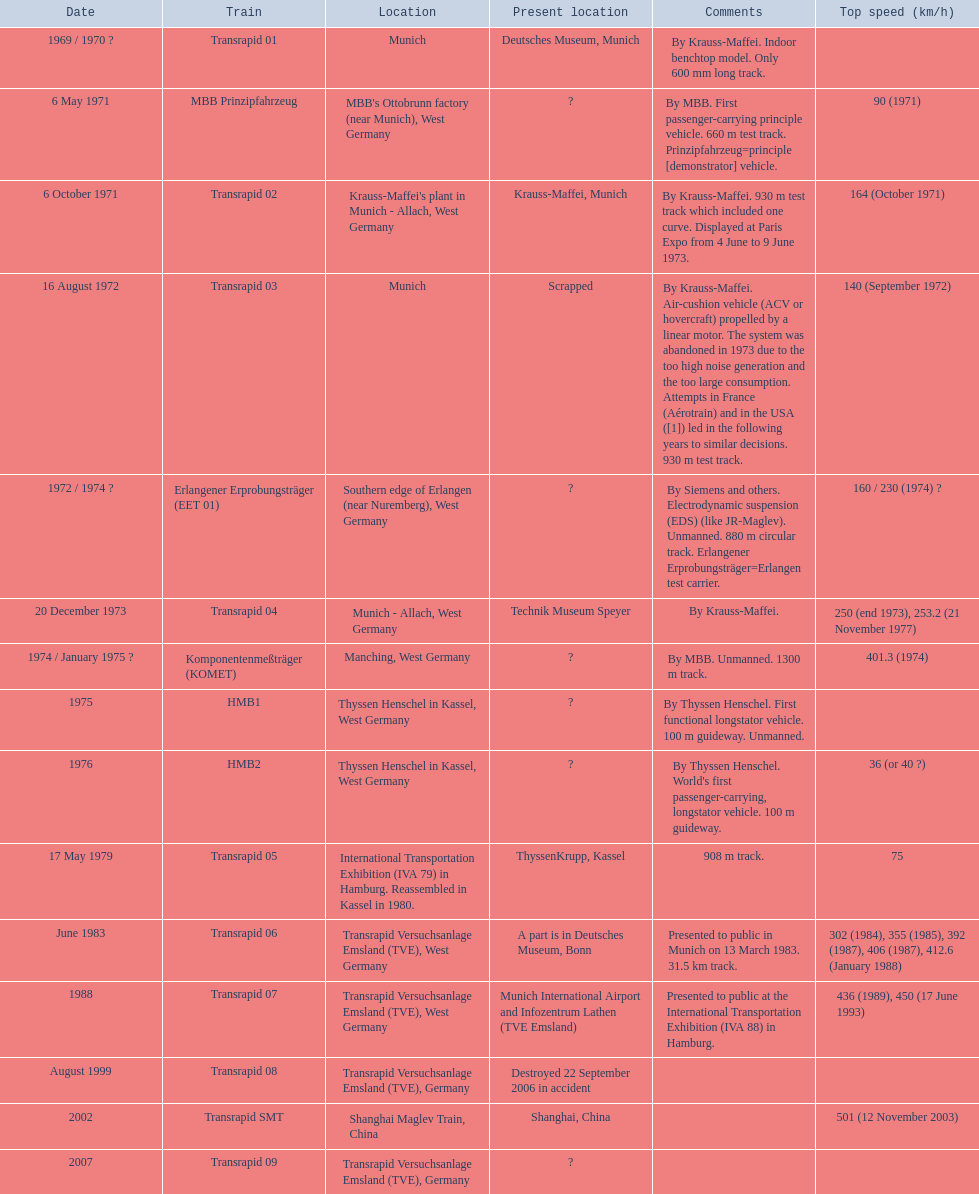Which trains surpassed a maximum speed of 400+? Komponentenmeßträger (KOMET), Transrapid 07, Transrapid SMT. And what about 500+? Transrapid SMT. 